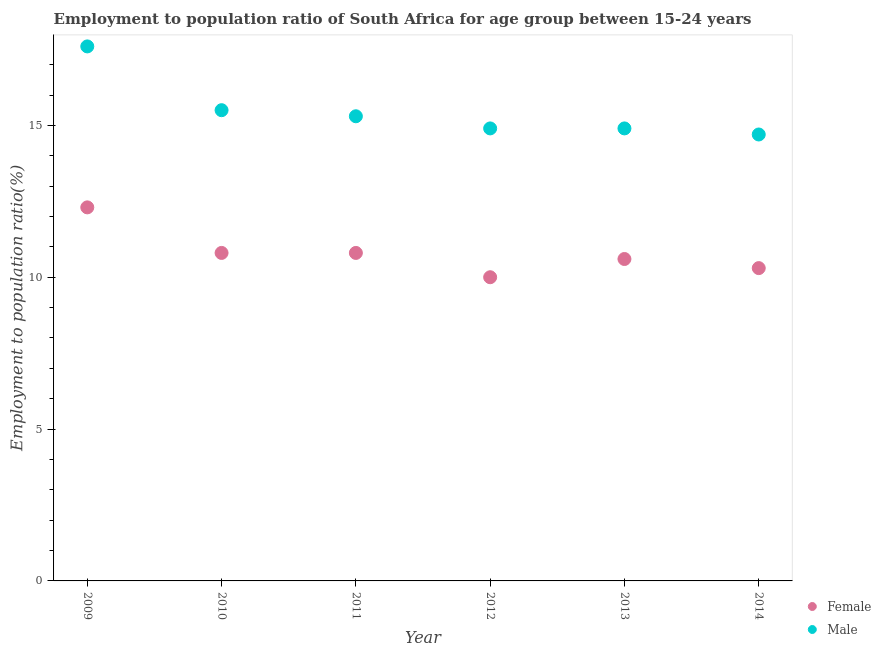How many different coloured dotlines are there?
Keep it short and to the point. 2. What is the employment to population ratio(female) in 2014?
Provide a short and direct response. 10.3. Across all years, what is the maximum employment to population ratio(female)?
Your answer should be compact. 12.3. Across all years, what is the minimum employment to population ratio(male)?
Provide a succinct answer. 14.7. What is the total employment to population ratio(male) in the graph?
Your response must be concise. 92.9. What is the difference between the employment to population ratio(male) in 2010 and that in 2014?
Give a very brief answer. 0.8. What is the difference between the employment to population ratio(female) in 2011 and the employment to population ratio(male) in 2009?
Your answer should be very brief. -6.8. What is the average employment to population ratio(female) per year?
Offer a terse response. 10.8. In the year 2010, what is the difference between the employment to population ratio(male) and employment to population ratio(female)?
Keep it short and to the point. 4.7. What is the ratio of the employment to population ratio(male) in 2011 to that in 2014?
Your response must be concise. 1.04. Is the employment to population ratio(male) in 2010 less than that in 2014?
Provide a succinct answer. No. What is the difference between the highest and the second highest employment to population ratio(male)?
Keep it short and to the point. 2.1. What is the difference between the highest and the lowest employment to population ratio(female)?
Keep it short and to the point. 2.3. In how many years, is the employment to population ratio(female) greater than the average employment to population ratio(female) taken over all years?
Provide a short and direct response. 3. Is the sum of the employment to population ratio(male) in 2009 and 2013 greater than the maximum employment to population ratio(female) across all years?
Your answer should be very brief. Yes. Does the employment to population ratio(female) monotonically increase over the years?
Offer a very short reply. No. Is the employment to population ratio(male) strictly greater than the employment to population ratio(female) over the years?
Your response must be concise. Yes. How many dotlines are there?
Your answer should be compact. 2. Are the values on the major ticks of Y-axis written in scientific E-notation?
Give a very brief answer. No. Does the graph contain any zero values?
Make the answer very short. No. Does the graph contain grids?
Ensure brevity in your answer.  No. How many legend labels are there?
Offer a terse response. 2. How are the legend labels stacked?
Make the answer very short. Vertical. What is the title of the graph?
Keep it short and to the point. Employment to population ratio of South Africa for age group between 15-24 years. What is the label or title of the Y-axis?
Make the answer very short. Employment to population ratio(%). What is the Employment to population ratio(%) of Female in 2009?
Offer a terse response. 12.3. What is the Employment to population ratio(%) of Male in 2009?
Give a very brief answer. 17.6. What is the Employment to population ratio(%) in Female in 2010?
Offer a terse response. 10.8. What is the Employment to population ratio(%) in Male in 2010?
Offer a very short reply. 15.5. What is the Employment to population ratio(%) in Female in 2011?
Your response must be concise. 10.8. What is the Employment to population ratio(%) of Male in 2011?
Make the answer very short. 15.3. What is the Employment to population ratio(%) of Female in 2012?
Offer a very short reply. 10. What is the Employment to population ratio(%) in Male in 2012?
Offer a very short reply. 14.9. What is the Employment to population ratio(%) in Female in 2013?
Make the answer very short. 10.6. What is the Employment to population ratio(%) of Male in 2013?
Your answer should be compact. 14.9. What is the Employment to population ratio(%) in Female in 2014?
Give a very brief answer. 10.3. What is the Employment to population ratio(%) of Male in 2014?
Offer a very short reply. 14.7. Across all years, what is the maximum Employment to population ratio(%) of Female?
Your response must be concise. 12.3. Across all years, what is the maximum Employment to population ratio(%) of Male?
Ensure brevity in your answer.  17.6. Across all years, what is the minimum Employment to population ratio(%) of Female?
Ensure brevity in your answer.  10. Across all years, what is the minimum Employment to population ratio(%) in Male?
Ensure brevity in your answer.  14.7. What is the total Employment to population ratio(%) of Female in the graph?
Keep it short and to the point. 64.8. What is the total Employment to population ratio(%) of Male in the graph?
Give a very brief answer. 92.9. What is the difference between the Employment to population ratio(%) in Female in 2009 and that in 2010?
Provide a succinct answer. 1.5. What is the difference between the Employment to population ratio(%) of Female in 2009 and that in 2011?
Offer a very short reply. 1.5. What is the difference between the Employment to population ratio(%) of Male in 2009 and that in 2011?
Your answer should be very brief. 2.3. What is the difference between the Employment to population ratio(%) in Female in 2009 and that in 2012?
Ensure brevity in your answer.  2.3. What is the difference between the Employment to population ratio(%) of Male in 2009 and that in 2013?
Your answer should be compact. 2.7. What is the difference between the Employment to population ratio(%) in Female in 2010 and that in 2012?
Provide a short and direct response. 0.8. What is the difference between the Employment to population ratio(%) in Male in 2010 and that in 2012?
Offer a very short reply. 0.6. What is the difference between the Employment to population ratio(%) in Female in 2011 and that in 2012?
Offer a very short reply. 0.8. What is the difference between the Employment to population ratio(%) in Male in 2011 and that in 2012?
Ensure brevity in your answer.  0.4. What is the difference between the Employment to population ratio(%) of Female in 2011 and that in 2014?
Offer a terse response. 0.5. What is the difference between the Employment to population ratio(%) in Male in 2011 and that in 2014?
Keep it short and to the point. 0.6. What is the difference between the Employment to population ratio(%) in Female in 2012 and that in 2013?
Offer a terse response. -0.6. What is the difference between the Employment to population ratio(%) of Male in 2012 and that in 2013?
Keep it short and to the point. 0. What is the difference between the Employment to population ratio(%) of Male in 2012 and that in 2014?
Keep it short and to the point. 0.2. What is the difference between the Employment to population ratio(%) of Female in 2009 and the Employment to population ratio(%) of Male in 2012?
Your response must be concise. -2.6. What is the difference between the Employment to population ratio(%) of Female in 2010 and the Employment to population ratio(%) of Male in 2012?
Your answer should be very brief. -4.1. What is the difference between the Employment to population ratio(%) in Female in 2010 and the Employment to population ratio(%) in Male in 2013?
Provide a short and direct response. -4.1. What is the difference between the Employment to population ratio(%) of Female in 2010 and the Employment to population ratio(%) of Male in 2014?
Your response must be concise. -3.9. What is the difference between the Employment to population ratio(%) of Female in 2012 and the Employment to population ratio(%) of Male in 2014?
Your response must be concise. -4.7. What is the difference between the Employment to population ratio(%) in Female in 2013 and the Employment to population ratio(%) in Male in 2014?
Offer a very short reply. -4.1. What is the average Employment to population ratio(%) in Female per year?
Offer a terse response. 10.8. What is the average Employment to population ratio(%) of Male per year?
Provide a short and direct response. 15.48. In the year 2009, what is the difference between the Employment to population ratio(%) in Female and Employment to population ratio(%) in Male?
Provide a succinct answer. -5.3. In the year 2011, what is the difference between the Employment to population ratio(%) of Female and Employment to population ratio(%) of Male?
Give a very brief answer. -4.5. What is the ratio of the Employment to population ratio(%) in Female in 2009 to that in 2010?
Provide a short and direct response. 1.14. What is the ratio of the Employment to population ratio(%) of Male in 2009 to that in 2010?
Give a very brief answer. 1.14. What is the ratio of the Employment to population ratio(%) in Female in 2009 to that in 2011?
Offer a terse response. 1.14. What is the ratio of the Employment to population ratio(%) of Male in 2009 to that in 2011?
Keep it short and to the point. 1.15. What is the ratio of the Employment to population ratio(%) in Female in 2009 to that in 2012?
Provide a succinct answer. 1.23. What is the ratio of the Employment to population ratio(%) in Male in 2009 to that in 2012?
Make the answer very short. 1.18. What is the ratio of the Employment to population ratio(%) of Female in 2009 to that in 2013?
Keep it short and to the point. 1.16. What is the ratio of the Employment to population ratio(%) of Male in 2009 to that in 2013?
Give a very brief answer. 1.18. What is the ratio of the Employment to population ratio(%) in Female in 2009 to that in 2014?
Your response must be concise. 1.19. What is the ratio of the Employment to population ratio(%) in Male in 2009 to that in 2014?
Your answer should be very brief. 1.2. What is the ratio of the Employment to population ratio(%) in Female in 2010 to that in 2011?
Keep it short and to the point. 1. What is the ratio of the Employment to population ratio(%) of Male in 2010 to that in 2011?
Offer a very short reply. 1.01. What is the ratio of the Employment to population ratio(%) of Female in 2010 to that in 2012?
Make the answer very short. 1.08. What is the ratio of the Employment to population ratio(%) in Male in 2010 to that in 2012?
Provide a short and direct response. 1.04. What is the ratio of the Employment to population ratio(%) in Female in 2010 to that in 2013?
Provide a short and direct response. 1.02. What is the ratio of the Employment to population ratio(%) of Male in 2010 to that in 2013?
Your answer should be very brief. 1.04. What is the ratio of the Employment to population ratio(%) in Female in 2010 to that in 2014?
Your response must be concise. 1.05. What is the ratio of the Employment to population ratio(%) in Male in 2010 to that in 2014?
Offer a very short reply. 1.05. What is the ratio of the Employment to population ratio(%) in Female in 2011 to that in 2012?
Your answer should be very brief. 1.08. What is the ratio of the Employment to population ratio(%) in Male in 2011 to that in 2012?
Give a very brief answer. 1.03. What is the ratio of the Employment to population ratio(%) in Female in 2011 to that in 2013?
Give a very brief answer. 1.02. What is the ratio of the Employment to population ratio(%) of Male in 2011 to that in 2013?
Keep it short and to the point. 1.03. What is the ratio of the Employment to population ratio(%) of Female in 2011 to that in 2014?
Ensure brevity in your answer.  1.05. What is the ratio of the Employment to population ratio(%) of Male in 2011 to that in 2014?
Offer a terse response. 1.04. What is the ratio of the Employment to population ratio(%) in Female in 2012 to that in 2013?
Your answer should be compact. 0.94. What is the ratio of the Employment to population ratio(%) in Male in 2012 to that in 2013?
Keep it short and to the point. 1. What is the ratio of the Employment to population ratio(%) in Female in 2012 to that in 2014?
Provide a short and direct response. 0.97. What is the ratio of the Employment to population ratio(%) in Male in 2012 to that in 2014?
Your answer should be very brief. 1.01. What is the ratio of the Employment to population ratio(%) in Female in 2013 to that in 2014?
Your answer should be compact. 1.03. What is the ratio of the Employment to population ratio(%) in Male in 2013 to that in 2014?
Your response must be concise. 1.01. What is the difference between the highest and the second highest Employment to population ratio(%) in Male?
Your response must be concise. 2.1. What is the difference between the highest and the lowest Employment to population ratio(%) of Female?
Provide a short and direct response. 2.3. What is the difference between the highest and the lowest Employment to population ratio(%) of Male?
Keep it short and to the point. 2.9. 